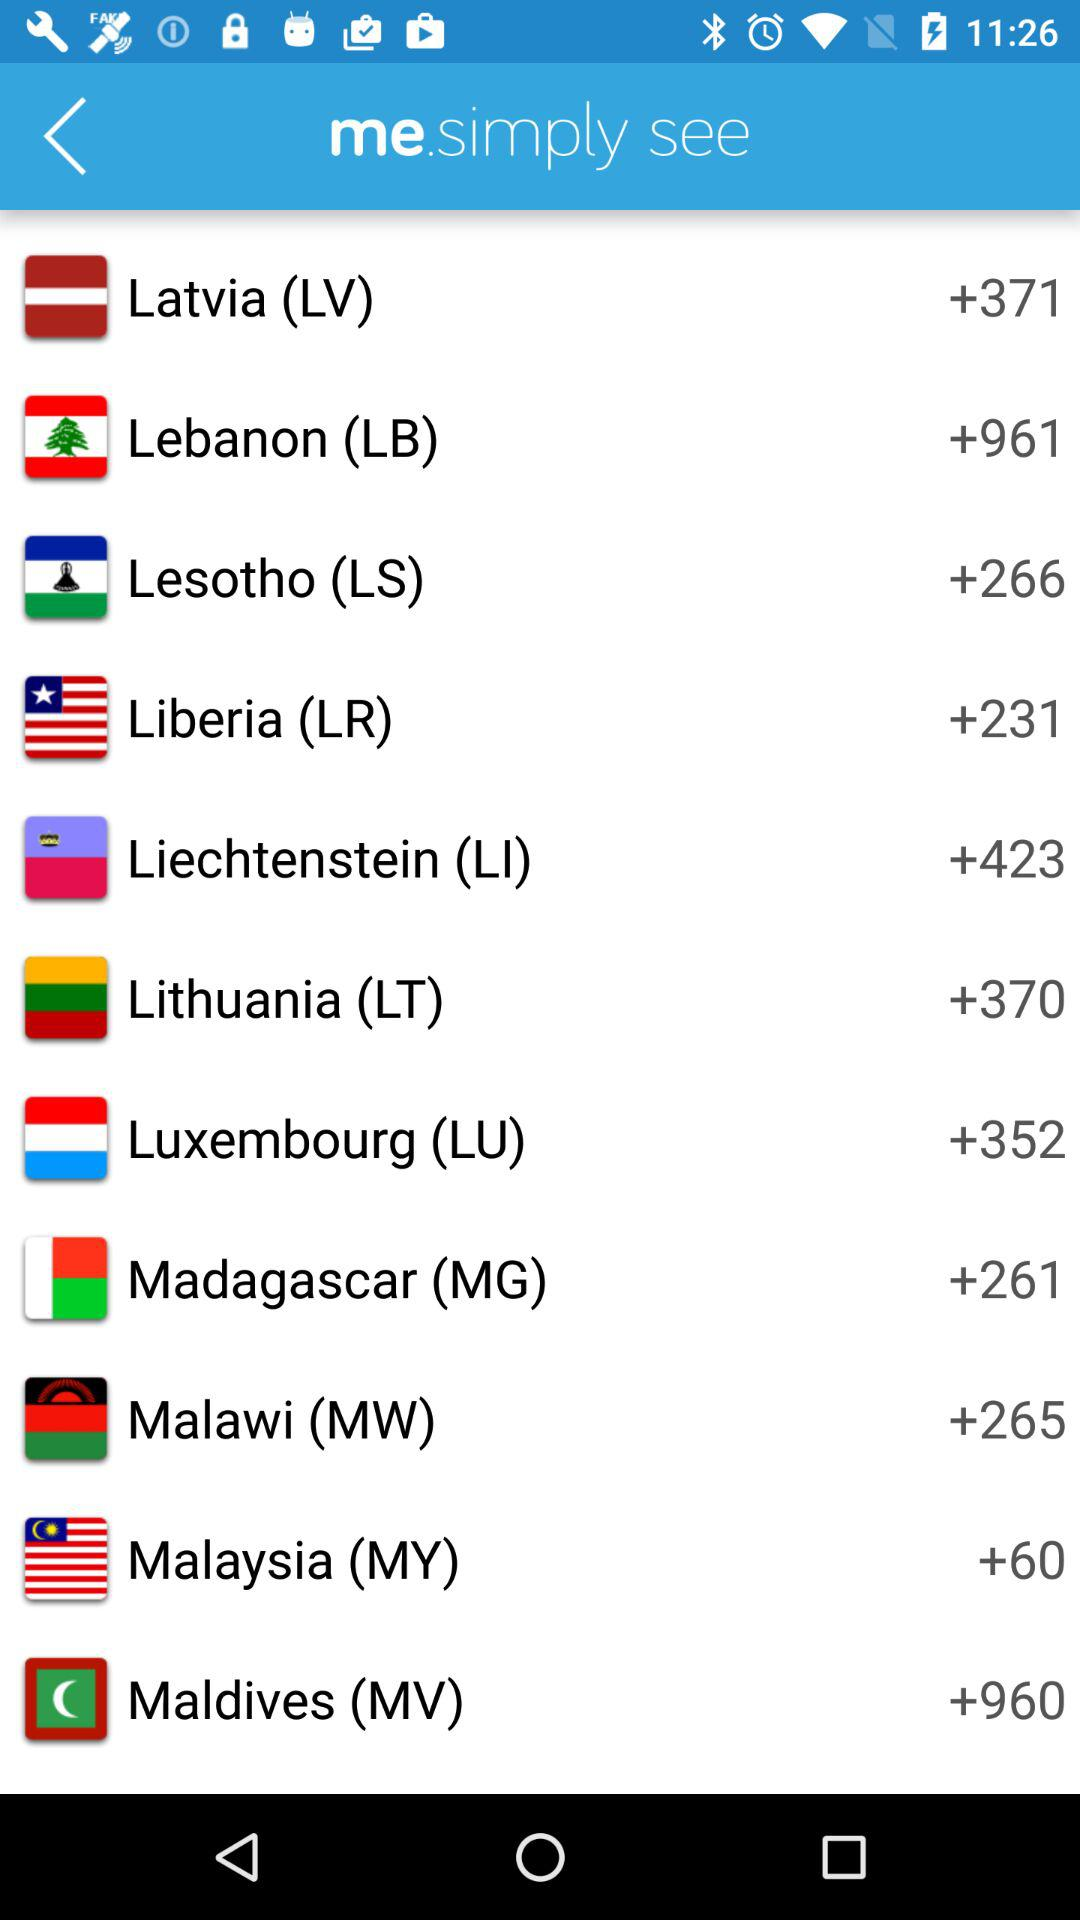MY is the internet country code of which country? MY is the internet country code of Malaysia. 